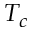Convert formula to latex. <formula><loc_0><loc_0><loc_500><loc_500>T _ { c }</formula> 